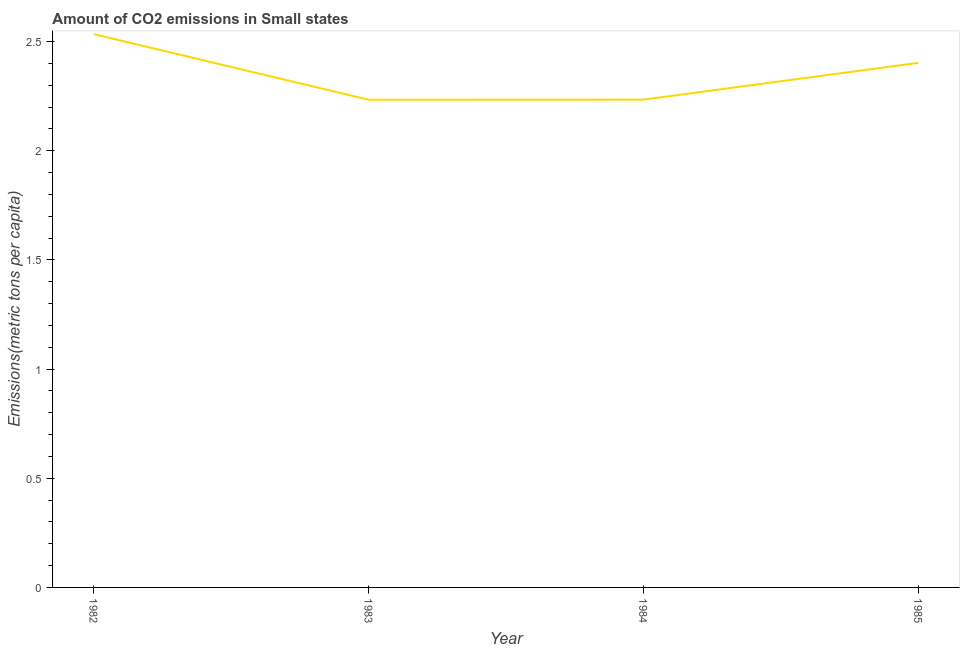What is the amount of co2 emissions in 1985?
Make the answer very short. 2.4. Across all years, what is the maximum amount of co2 emissions?
Provide a succinct answer. 2.53. Across all years, what is the minimum amount of co2 emissions?
Make the answer very short. 2.23. In which year was the amount of co2 emissions minimum?
Provide a succinct answer. 1983. What is the sum of the amount of co2 emissions?
Ensure brevity in your answer.  9.4. What is the difference between the amount of co2 emissions in 1982 and 1985?
Make the answer very short. 0.13. What is the average amount of co2 emissions per year?
Your answer should be compact. 2.35. What is the median amount of co2 emissions?
Offer a very short reply. 2.32. In how many years, is the amount of co2 emissions greater than 0.1 metric tons per capita?
Make the answer very short. 4. What is the ratio of the amount of co2 emissions in 1982 to that in 1983?
Give a very brief answer. 1.13. Is the amount of co2 emissions in 1984 less than that in 1985?
Provide a short and direct response. Yes. What is the difference between the highest and the second highest amount of co2 emissions?
Keep it short and to the point. 0.13. What is the difference between the highest and the lowest amount of co2 emissions?
Offer a terse response. 0.3. In how many years, is the amount of co2 emissions greater than the average amount of co2 emissions taken over all years?
Your answer should be compact. 2. Does the amount of co2 emissions monotonically increase over the years?
Your answer should be very brief. No. How many years are there in the graph?
Ensure brevity in your answer.  4. What is the difference between two consecutive major ticks on the Y-axis?
Keep it short and to the point. 0.5. Are the values on the major ticks of Y-axis written in scientific E-notation?
Your response must be concise. No. Does the graph contain grids?
Offer a very short reply. No. What is the title of the graph?
Provide a succinct answer. Amount of CO2 emissions in Small states. What is the label or title of the Y-axis?
Give a very brief answer. Emissions(metric tons per capita). What is the Emissions(metric tons per capita) of 1982?
Offer a terse response. 2.53. What is the Emissions(metric tons per capita) of 1983?
Provide a succinct answer. 2.23. What is the Emissions(metric tons per capita) of 1984?
Your response must be concise. 2.23. What is the Emissions(metric tons per capita) in 1985?
Your response must be concise. 2.4. What is the difference between the Emissions(metric tons per capita) in 1982 and 1983?
Make the answer very short. 0.3. What is the difference between the Emissions(metric tons per capita) in 1982 and 1984?
Make the answer very short. 0.3. What is the difference between the Emissions(metric tons per capita) in 1982 and 1985?
Offer a terse response. 0.13. What is the difference between the Emissions(metric tons per capita) in 1983 and 1984?
Provide a short and direct response. -0. What is the difference between the Emissions(metric tons per capita) in 1983 and 1985?
Provide a short and direct response. -0.17. What is the difference between the Emissions(metric tons per capita) in 1984 and 1985?
Provide a short and direct response. -0.17. What is the ratio of the Emissions(metric tons per capita) in 1982 to that in 1983?
Provide a short and direct response. 1.13. What is the ratio of the Emissions(metric tons per capita) in 1982 to that in 1984?
Your response must be concise. 1.13. What is the ratio of the Emissions(metric tons per capita) in 1982 to that in 1985?
Give a very brief answer. 1.05. What is the ratio of the Emissions(metric tons per capita) in 1983 to that in 1984?
Your answer should be very brief. 1. 